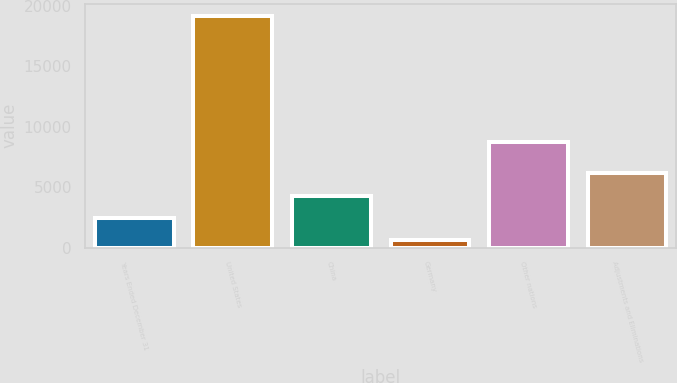<chart> <loc_0><loc_0><loc_500><loc_500><bar_chart><fcel>Years Ended December 31<fcel>United States<fcel>China<fcel>Germany<fcel>Other nations<fcel>Adjustments and Eliminations<nl><fcel>2441.9<fcel>19190<fcel>4302.8<fcel>581<fcel>8734<fcel>6163.7<nl></chart> 